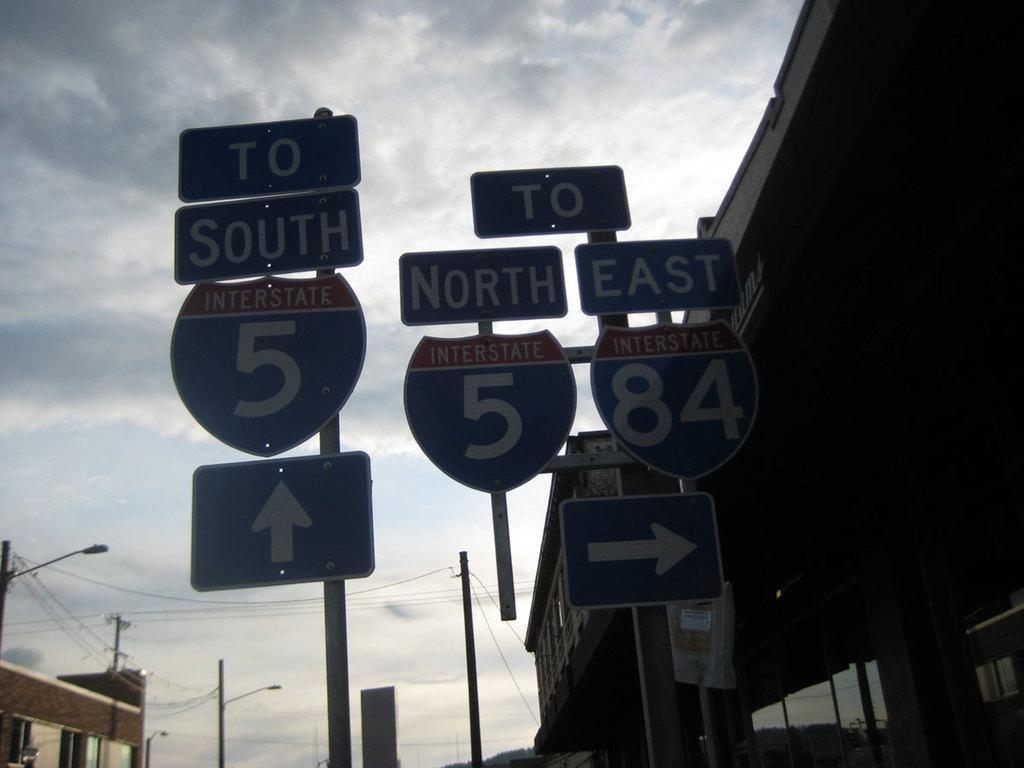Please provide a concise description of this image. This image is taken outdoors. At the top of the image there is a sky with clouds. In the middle of the image there are many sign boards with text on them. There is a pole with a few wires. On the left side of the image there is a building and there are a few street lights. On the right side of the image there is a building. 